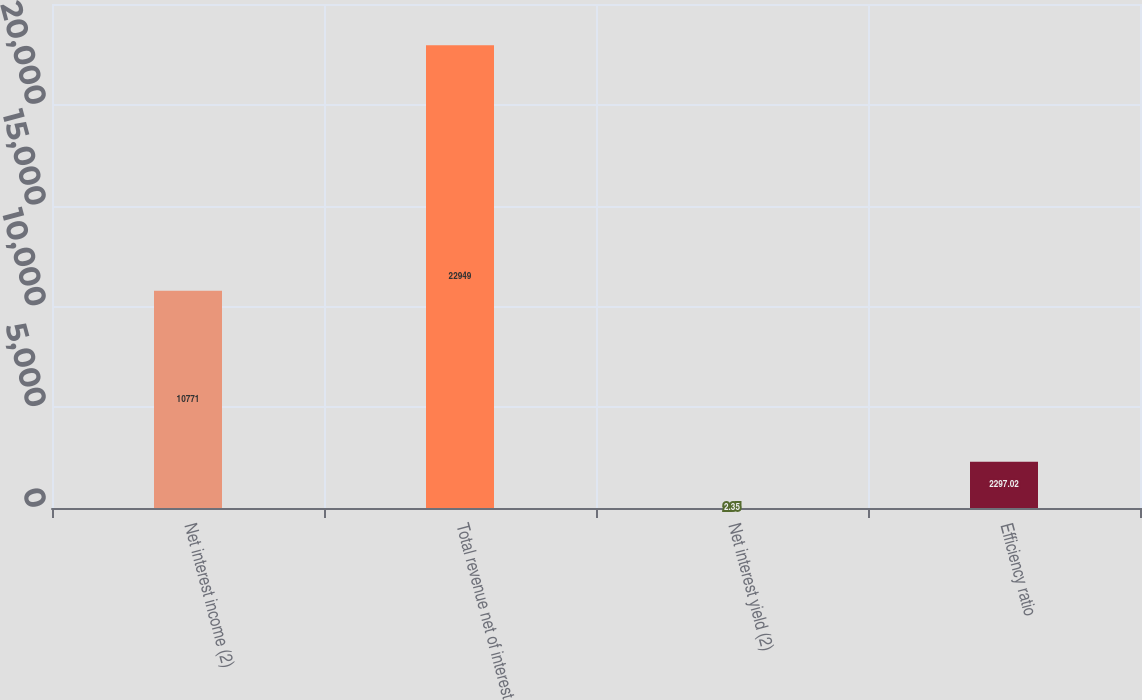Convert chart to OTSL. <chart><loc_0><loc_0><loc_500><loc_500><bar_chart><fcel>Net interest income (2)<fcel>Total revenue net of interest<fcel>Net interest yield (2)<fcel>Efficiency ratio<nl><fcel>10771<fcel>22949<fcel>2.35<fcel>2297.02<nl></chart> 